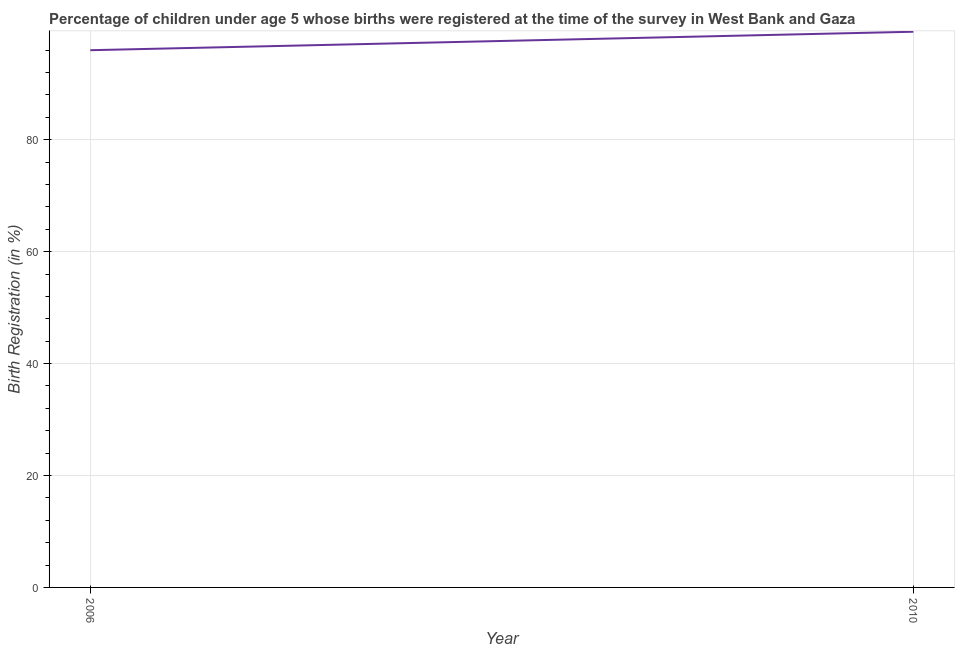What is the birth registration in 2010?
Offer a terse response. 99.3. Across all years, what is the maximum birth registration?
Make the answer very short. 99.3. Across all years, what is the minimum birth registration?
Keep it short and to the point. 96. What is the sum of the birth registration?
Your answer should be very brief. 195.3. What is the difference between the birth registration in 2006 and 2010?
Offer a terse response. -3.3. What is the average birth registration per year?
Offer a terse response. 97.65. What is the median birth registration?
Your answer should be very brief. 97.65. In how many years, is the birth registration greater than 8 %?
Provide a succinct answer. 2. Do a majority of the years between 2010 and 2006 (inclusive) have birth registration greater than 56 %?
Your answer should be very brief. No. What is the ratio of the birth registration in 2006 to that in 2010?
Your answer should be very brief. 0.97. Does the birth registration monotonically increase over the years?
Your answer should be very brief. Yes. How many years are there in the graph?
Ensure brevity in your answer.  2. Are the values on the major ticks of Y-axis written in scientific E-notation?
Ensure brevity in your answer.  No. Does the graph contain any zero values?
Offer a terse response. No. What is the title of the graph?
Offer a terse response. Percentage of children under age 5 whose births were registered at the time of the survey in West Bank and Gaza. What is the label or title of the X-axis?
Your response must be concise. Year. What is the label or title of the Y-axis?
Your answer should be compact. Birth Registration (in %). What is the Birth Registration (in %) in 2006?
Keep it short and to the point. 96. What is the Birth Registration (in %) in 2010?
Provide a succinct answer. 99.3. What is the difference between the Birth Registration (in %) in 2006 and 2010?
Offer a very short reply. -3.3. What is the ratio of the Birth Registration (in %) in 2006 to that in 2010?
Offer a terse response. 0.97. 